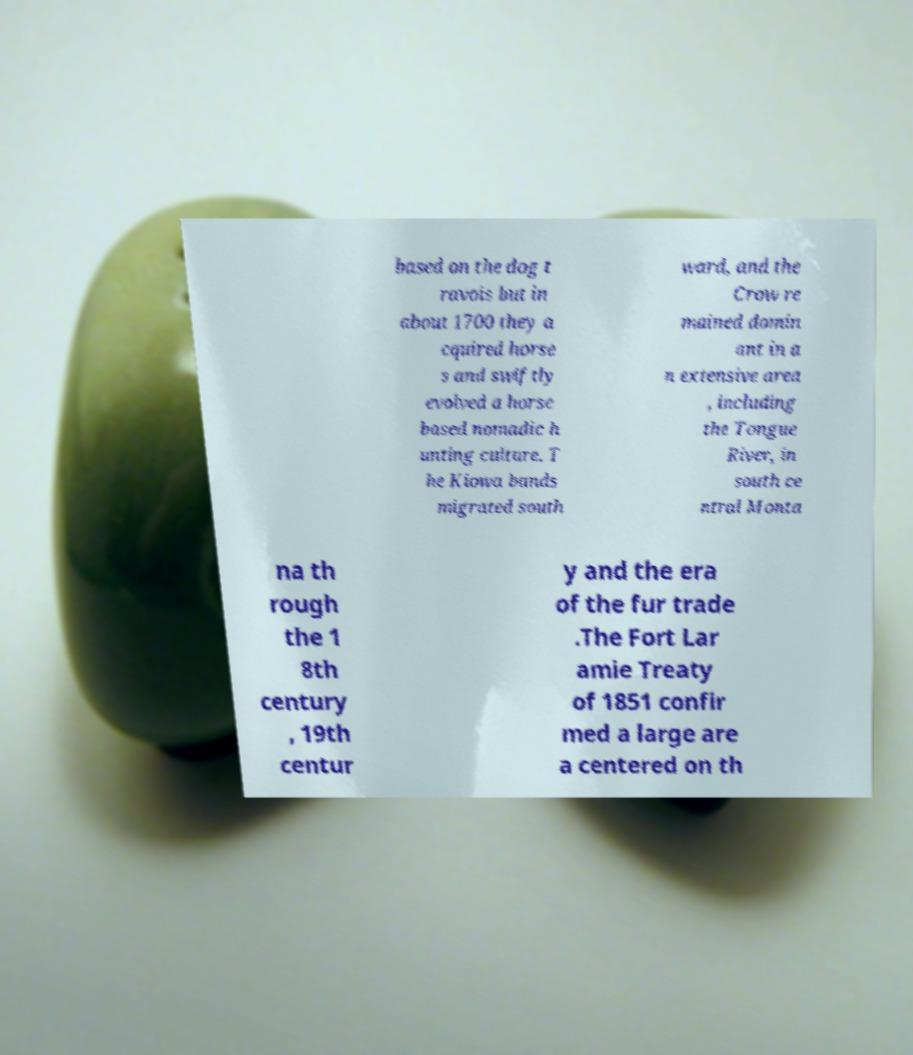There's text embedded in this image that I need extracted. Can you transcribe it verbatim? based on the dog t ravois but in about 1700 they a cquired horse s and swiftly evolved a horse based nomadic h unting culture. T he Kiowa bands migrated south ward, and the Crow re mained domin ant in a n extensive area , including the Tongue River, in south ce ntral Monta na th rough the 1 8th century , 19th centur y and the era of the fur trade .The Fort Lar amie Treaty of 1851 confir med a large are a centered on th 